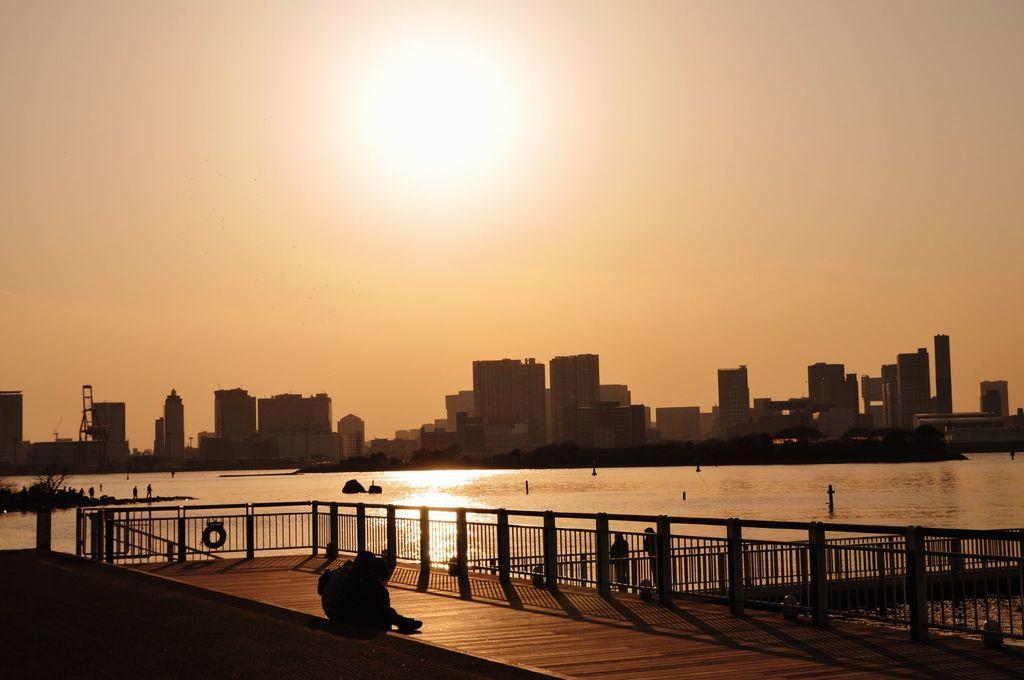Can you describe this image briefly? In this picture we can see the iron grilles and some people are standing and a person is sitting. Behind the iron grilles there is the water, buildings and the sky. 